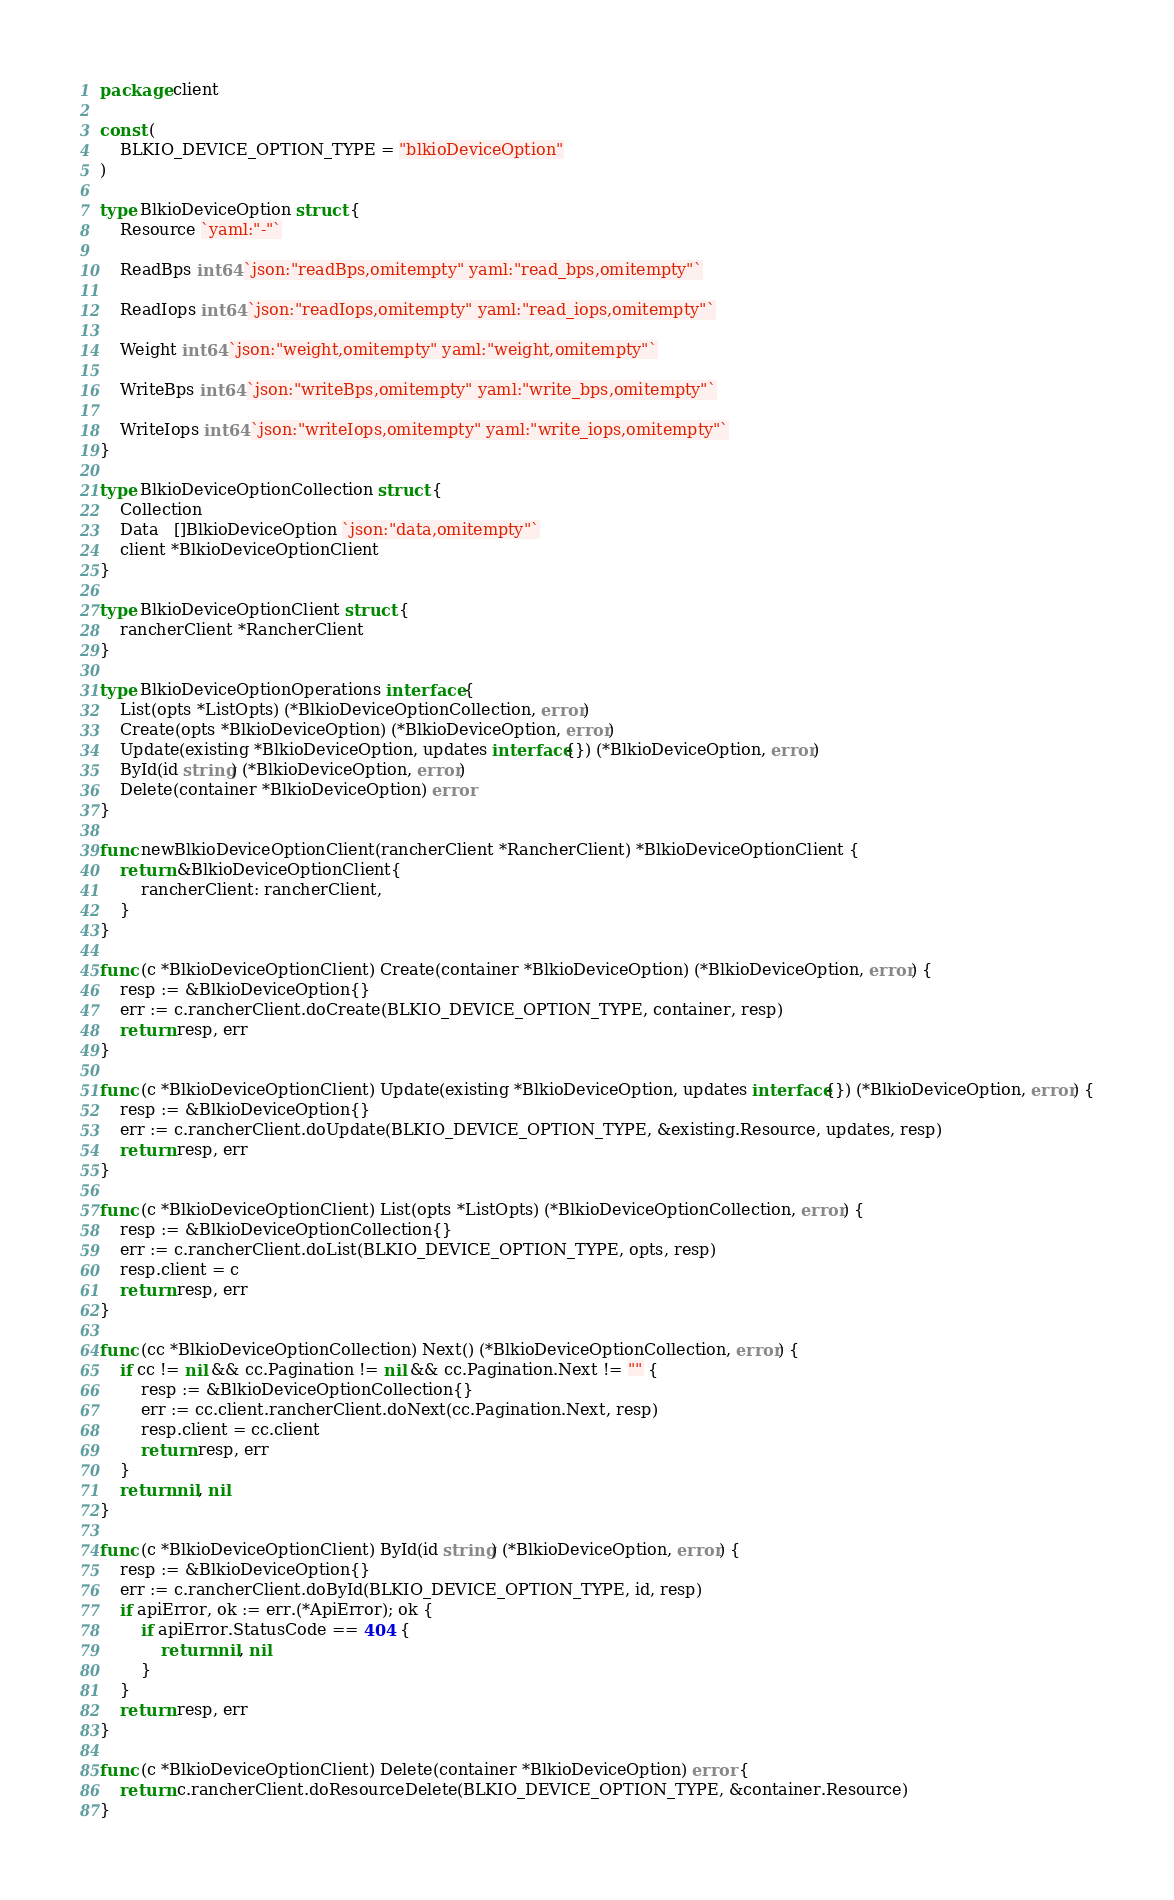<code> <loc_0><loc_0><loc_500><loc_500><_Go_>package client

const (
	BLKIO_DEVICE_OPTION_TYPE = "blkioDeviceOption"
)

type BlkioDeviceOption struct {
	Resource `yaml:"-"`

	ReadBps int64 `json:"readBps,omitempty" yaml:"read_bps,omitempty"`

	ReadIops int64 `json:"readIops,omitempty" yaml:"read_iops,omitempty"`

	Weight int64 `json:"weight,omitempty" yaml:"weight,omitempty"`

	WriteBps int64 `json:"writeBps,omitempty" yaml:"write_bps,omitempty"`

	WriteIops int64 `json:"writeIops,omitempty" yaml:"write_iops,omitempty"`
}

type BlkioDeviceOptionCollection struct {
	Collection
	Data   []BlkioDeviceOption `json:"data,omitempty"`
	client *BlkioDeviceOptionClient
}

type BlkioDeviceOptionClient struct {
	rancherClient *RancherClient
}

type BlkioDeviceOptionOperations interface {
	List(opts *ListOpts) (*BlkioDeviceOptionCollection, error)
	Create(opts *BlkioDeviceOption) (*BlkioDeviceOption, error)
	Update(existing *BlkioDeviceOption, updates interface{}) (*BlkioDeviceOption, error)
	ById(id string) (*BlkioDeviceOption, error)
	Delete(container *BlkioDeviceOption) error
}

func newBlkioDeviceOptionClient(rancherClient *RancherClient) *BlkioDeviceOptionClient {
	return &BlkioDeviceOptionClient{
		rancherClient: rancherClient,
	}
}

func (c *BlkioDeviceOptionClient) Create(container *BlkioDeviceOption) (*BlkioDeviceOption, error) {
	resp := &BlkioDeviceOption{}
	err := c.rancherClient.doCreate(BLKIO_DEVICE_OPTION_TYPE, container, resp)
	return resp, err
}

func (c *BlkioDeviceOptionClient) Update(existing *BlkioDeviceOption, updates interface{}) (*BlkioDeviceOption, error) {
	resp := &BlkioDeviceOption{}
	err := c.rancherClient.doUpdate(BLKIO_DEVICE_OPTION_TYPE, &existing.Resource, updates, resp)
	return resp, err
}

func (c *BlkioDeviceOptionClient) List(opts *ListOpts) (*BlkioDeviceOptionCollection, error) {
	resp := &BlkioDeviceOptionCollection{}
	err := c.rancherClient.doList(BLKIO_DEVICE_OPTION_TYPE, opts, resp)
	resp.client = c
	return resp, err
}

func (cc *BlkioDeviceOptionCollection) Next() (*BlkioDeviceOptionCollection, error) {
	if cc != nil && cc.Pagination != nil && cc.Pagination.Next != "" {
		resp := &BlkioDeviceOptionCollection{}
		err := cc.client.rancherClient.doNext(cc.Pagination.Next, resp)
		resp.client = cc.client
		return resp, err
	}
	return nil, nil
}

func (c *BlkioDeviceOptionClient) ById(id string) (*BlkioDeviceOption, error) {
	resp := &BlkioDeviceOption{}
	err := c.rancherClient.doById(BLKIO_DEVICE_OPTION_TYPE, id, resp)
	if apiError, ok := err.(*ApiError); ok {
		if apiError.StatusCode == 404 {
			return nil, nil
		}
	}
	return resp, err
}

func (c *BlkioDeviceOptionClient) Delete(container *BlkioDeviceOption) error {
	return c.rancherClient.doResourceDelete(BLKIO_DEVICE_OPTION_TYPE, &container.Resource)
}
</code> 